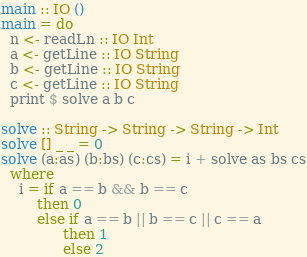Convert code to text. <code><loc_0><loc_0><loc_500><loc_500><_Haskell_>main :: IO ()
main = do
  n <- readLn :: IO Int
  a <- getLine :: IO String
  b <- getLine :: IO String
  c <- getLine :: IO String
  print $ solve a b c

solve :: String -> String -> String -> Int
solve [] _ _ = 0
solve (a:as) (b:bs) (c:cs) = i + solve as bs cs
  where
    i = if a == b && b == c
        then 0
        else if a == b || b == c || c == a
              then 1
              else 2</code> 